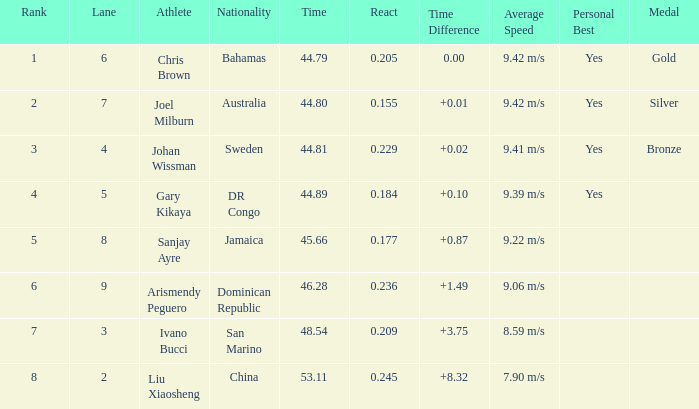How many total Time listings have a 0.209 React entry and a Rank that is greater than 7? 0.0. 